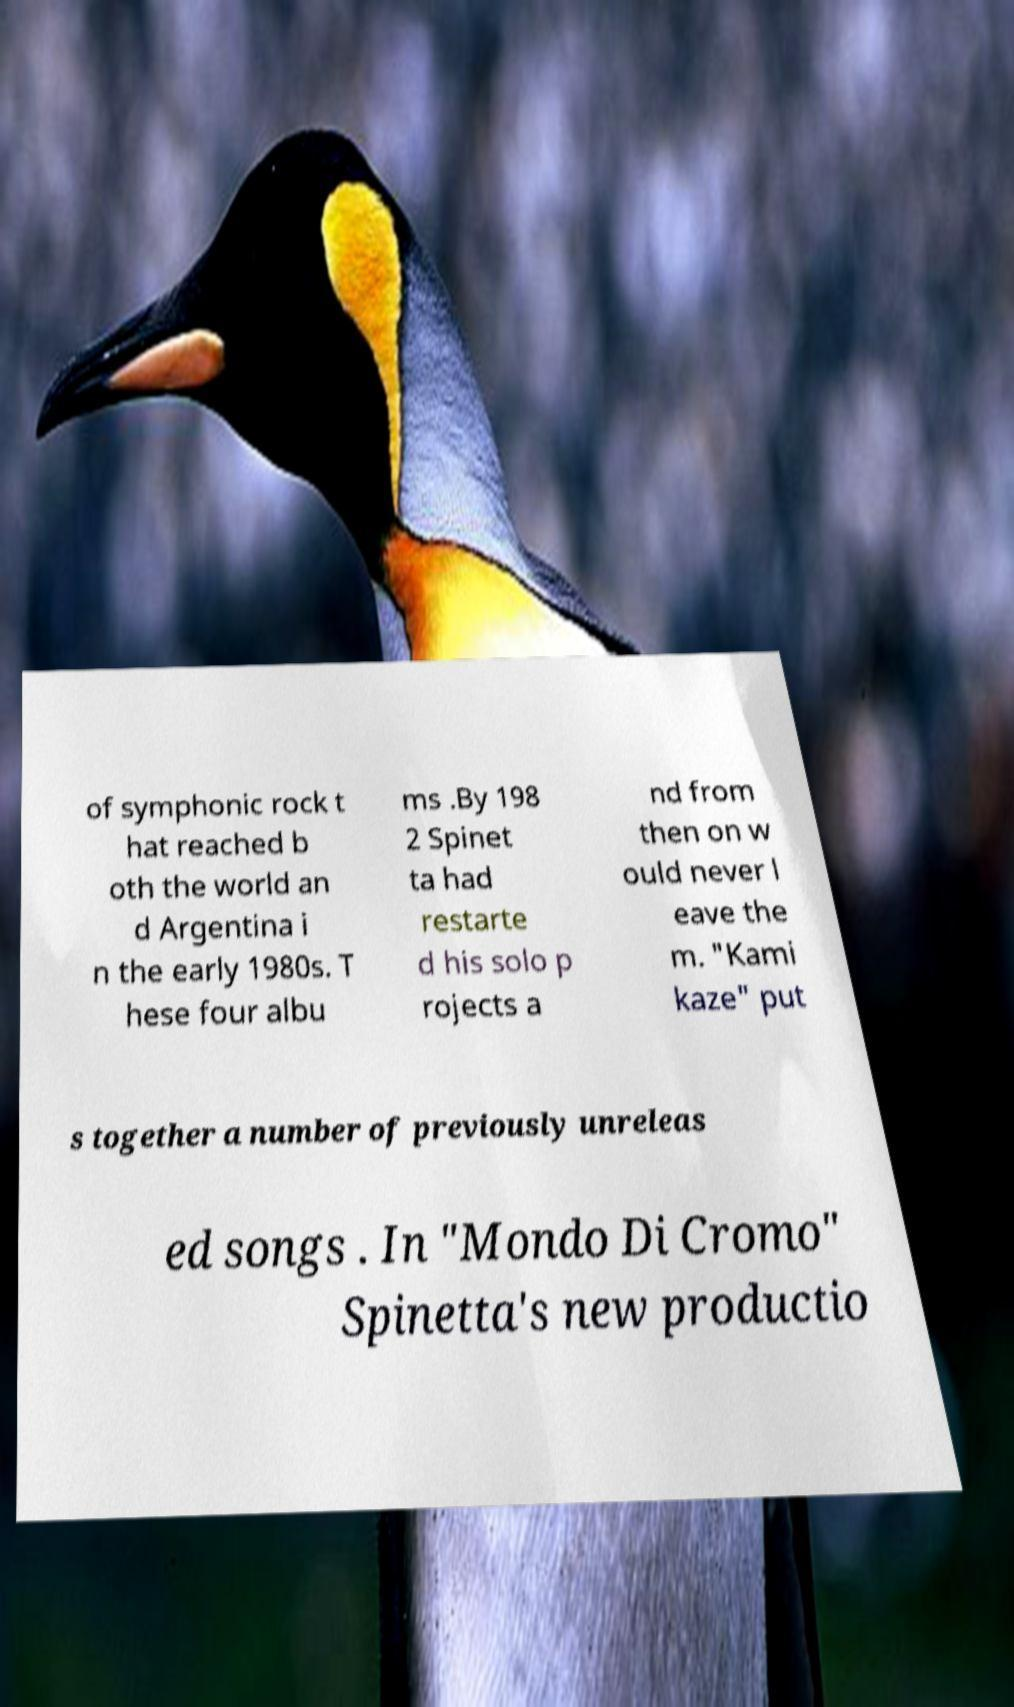For documentation purposes, I need the text within this image transcribed. Could you provide that? of symphonic rock t hat reached b oth the world an d Argentina i n the early 1980s. T hese four albu ms .By 198 2 Spinet ta had restarte d his solo p rojects a nd from then on w ould never l eave the m. "Kami kaze" put s together a number of previously unreleas ed songs . In "Mondo Di Cromo" Spinetta's new productio 